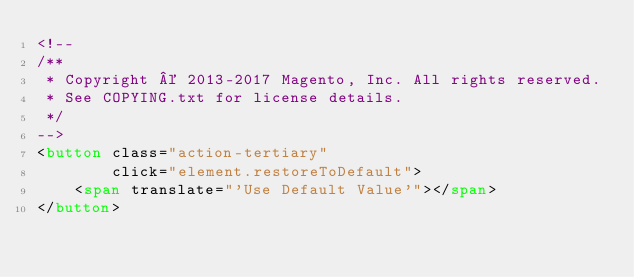<code> <loc_0><loc_0><loc_500><loc_500><_HTML_><!--
/**
 * Copyright © 2013-2017 Magento, Inc. All rights reserved.
 * See COPYING.txt for license details.
 */
-->
<button class="action-tertiary"
        click="element.restoreToDefault">
    <span translate="'Use Default Value'"></span>
</button>
</code> 